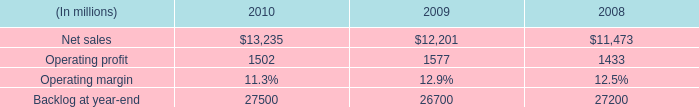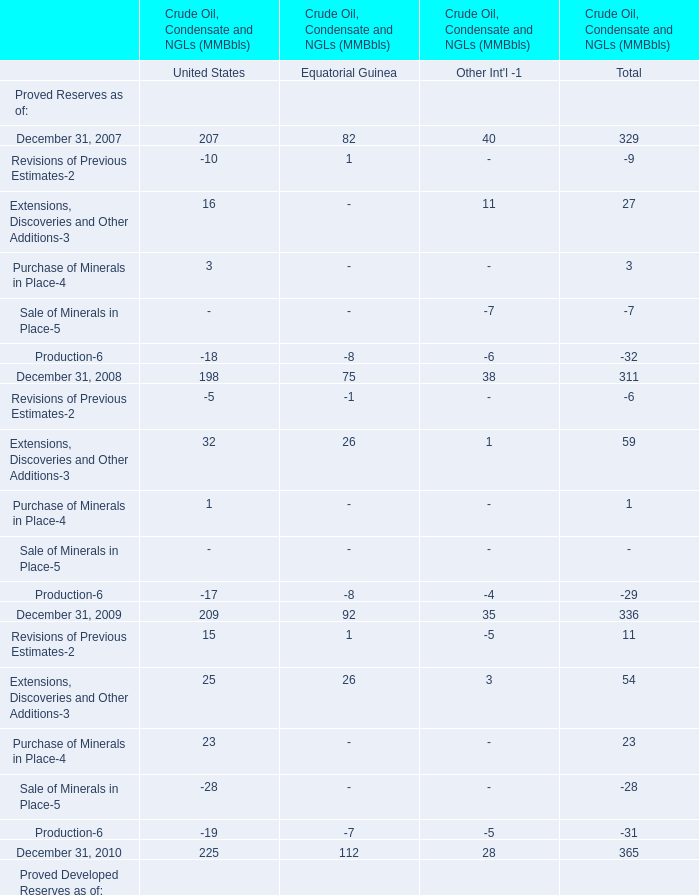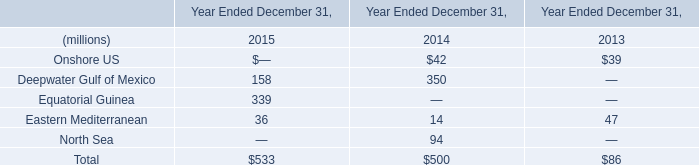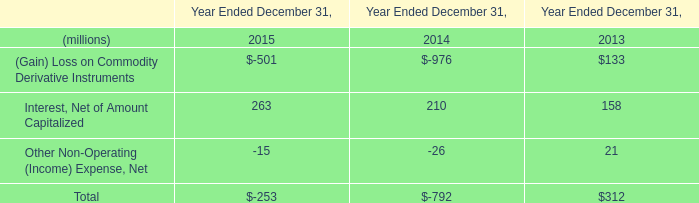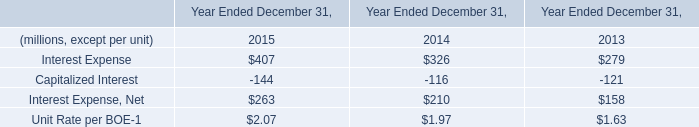In the year with lowest amount of Other Non-Operating (Income) Expense, Net in Table 3, what's the increasing rate of Interest Expense in Table 4? 
Computations: ((326 - 279) / 279)
Answer: 0.16846. 